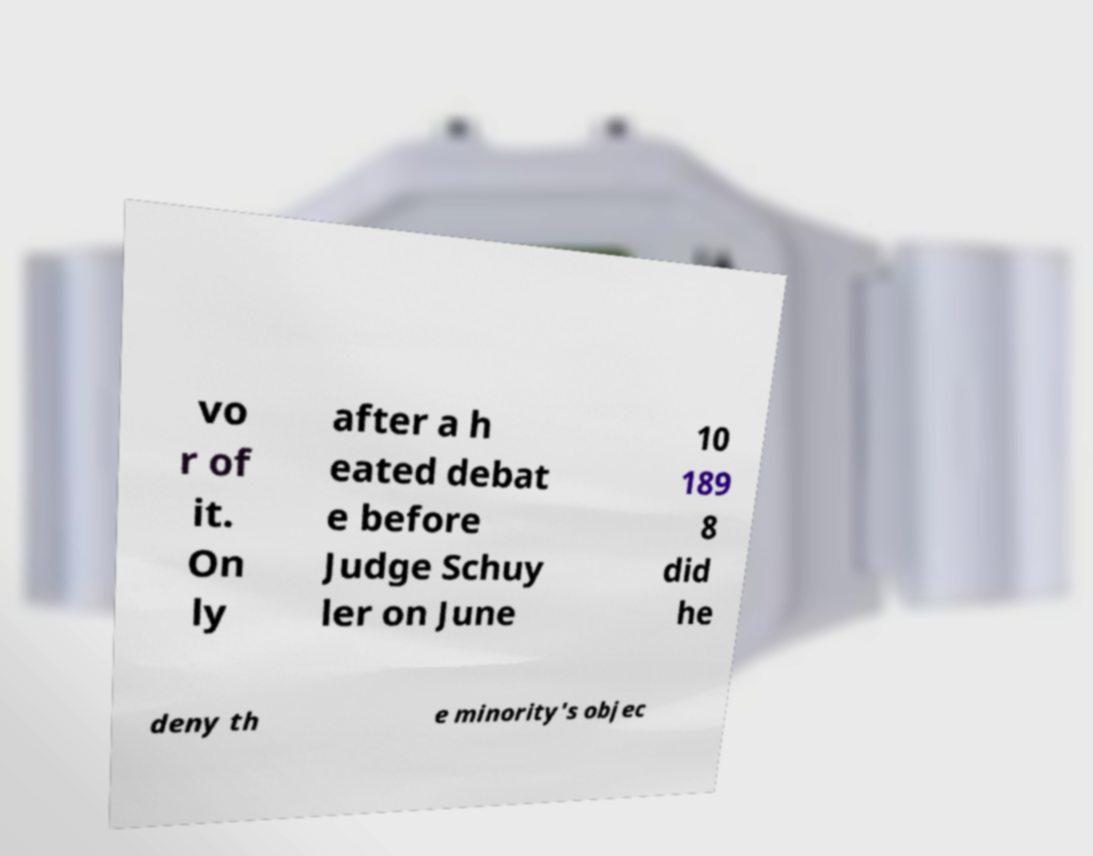Could you assist in decoding the text presented in this image and type it out clearly? vo r of it. On ly after a h eated debat e before Judge Schuy ler on June 10 189 8 did he deny th e minority's objec 